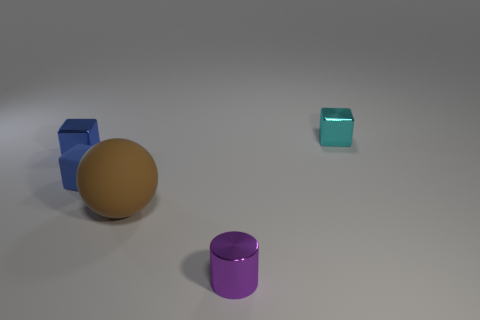Is there any other thing that is the same size as the brown matte sphere?
Keep it short and to the point. No. How many shiny objects are the same size as the purple cylinder?
Offer a very short reply. 2. Do the metal block that is left of the purple metallic cylinder and the ball behind the small cylinder have the same size?
Give a very brief answer. No. There is a matte object that is behind the big brown sphere; what size is it?
Your answer should be very brief. Small. There is a brown matte object to the right of the small shiny block that is to the left of the cylinder; what size is it?
Offer a terse response. Large. There is a cylinder that is the same size as the blue rubber cube; what material is it?
Your response must be concise. Metal. Are there any small purple objects to the right of the small blue metallic block?
Ensure brevity in your answer.  Yes. Is the number of big matte things behind the cyan cube the same as the number of large brown spheres?
Offer a terse response. No. There is a purple shiny thing that is the same size as the blue rubber block; what shape is it?
Offer a terse response. Cylinder. What is the large brown ball made of?
Provide a succinct answer. Rubber. 